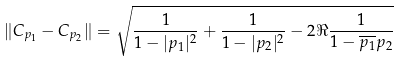<formula> <loc_0><loc_0><loc_500><loc_500>\| C _ { p _ { 1 } } - C _ { p _ { 2 } } \| = \sqrt { \frac { 1 } { 1 - | p _ { 1 } | ^ { 2 } } + \frac { 1 } { 1 - | p _ { 2 } | ^ { 2 } } - 2 \Re \frac { 1 } { { 1 - \overline { p _ { 1 } } p _ { 2 } } } }</formula> 